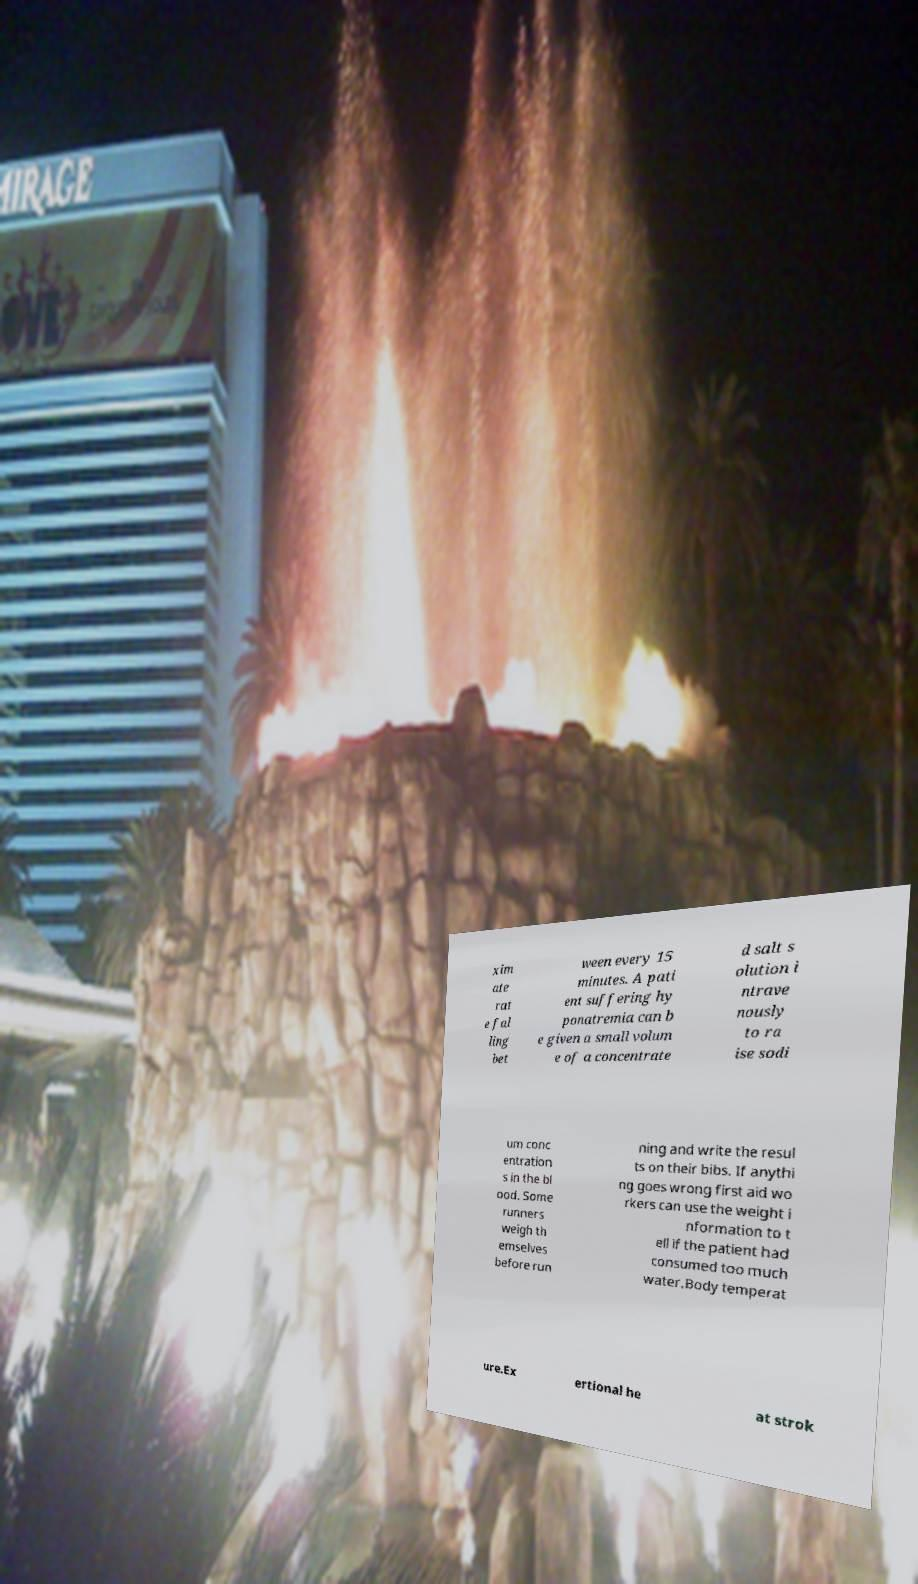Could you assist in decoding the text presented in this image and type it out clearly? xim ate rat e fal ling bet ween every 15 minutes. A pati ent suffering hy ponatremia can b e given a small volum e of a concentrate d salt s olution i ntrave nously to ra ise sodi um conc entration s in the bl ood. Some runners weigh th emselves before run ning and write the resul ts on their bibs. If anythi ng goes wrong first aid wo rkers can use the weight i nformation to t ell if the patient had consumed too much water.Body temperat ure.Ex ertional he at strok 